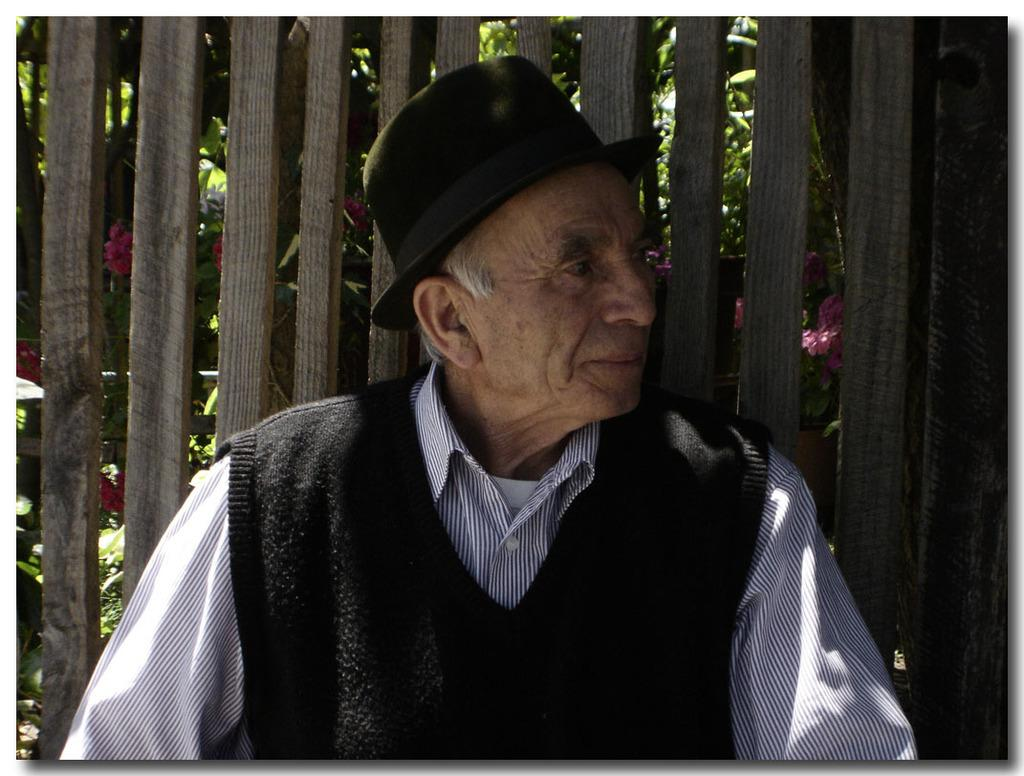Who is the main subject in the image? There is an old man in the image. What is the old man wearing on his head? The old man is wearing a black color hat. What can be seen behind the old man? There are wooden sticks visible behind the man, and trees are present behind the wooden sticks. What other elements are present in the image? Flowers are also visible in the image. What type of humor is the old man telling in the image? There is no indication of humor or any conversation in the image; it simply shows an old man wearing a black color hat with wooden sticks, trees, and flowers in the background. 